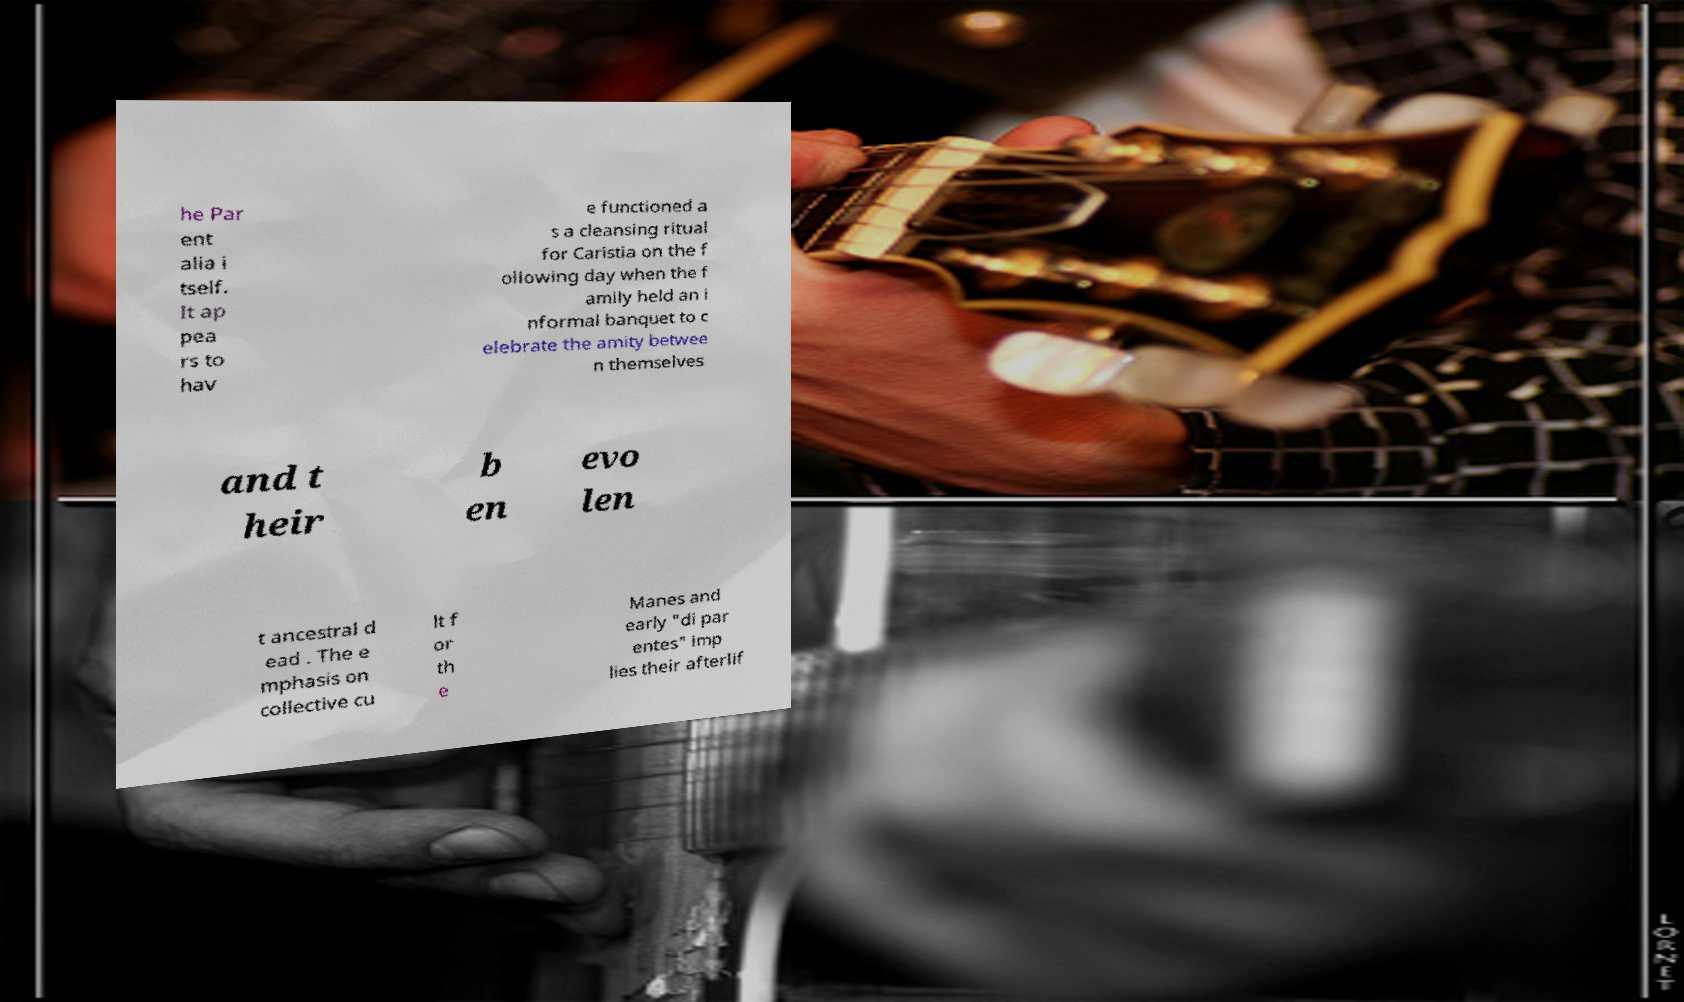Could you extract and type out the text from this image? he Par ent alia i tself. It ap pea rs to hav e functioned a s a cleansing ritual for Caristia on the f ollowing day when the f amily held an i nformal banquet to c elebrate the amity betwee n themselves and t heir b en evo len t ancestral d ead . The e mphasis on collective cu lt f or th e Manes and early "di par entes" imp lies their afterlif 